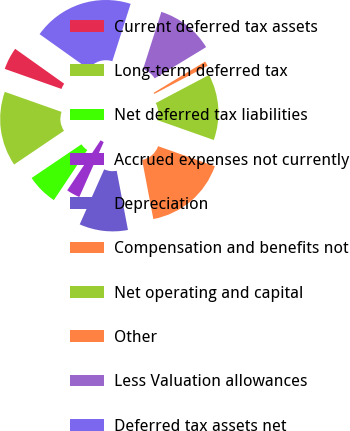<chart> <loc_0><loc_0><loc_500><loc_500><pie_chart><fcel>Current deferred tax assets<fcel>Long-term deferred tax<fcel>Net deferred tax liabilities<fcel>Accrued expenses not currently<fcel>Depreciation<fcel>Compensation and benefits not<fcel>Net operating and capital<fcel>Other<fcel>Less Valuation allowances<fcel>Deferred tax assets net<nl><fcel>4.44%<fcel>14.87%<fcel>6.18%<fcel>2.7%<fcel>9.65%<fcel>16.61%<fcel>13.13%<fcel>0.96%<fcel>11.39%<fcel>20.08%<nl></chart> 